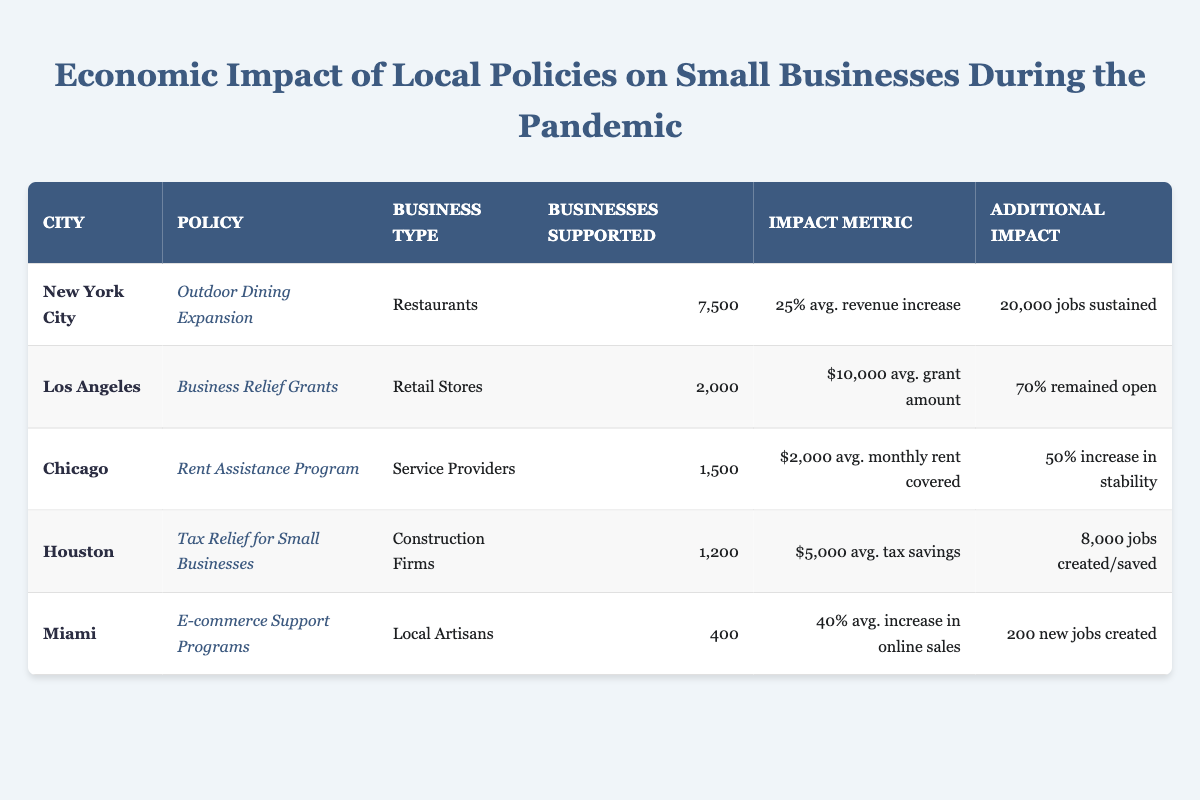What is the average revenue increase percentage for restaurants in New York City? The table indicates that the average revenue increase percentage for restaurants under the Outdoor Dining Expansion policy in New York City is 25%.
Answer: 25% How many small businesses were supported by the Business Relief Grants policy in Los Angeles? The table states that the Business Relief Grants policy in Los Angeles supported 2,000 retail stores.
Answer: 2000 Did the Rent Assistance Program in Chicago contribute to an increase in business stability? The table shows a 50% increase in business stability for service providers supported by the Rent Assistance Program. Therefore, the statement is true.
Answer: Yes What is the total number of businesses supported by all policies listed in the table? To find the total number of businesses supported, I sum the number of supported businesses for each city: 7500 (NYC) + 2000 (LA) + 1500 (Chicago) + 1200 (Houston) + 400 (Miami) = 13,600.
Answer: 13600 How many jobs were either created or saved due to tax relief for small businesses in Houston? According to the table, the Tax Relief for Small Businesses policy in Houston resulted in 8,000 jobs created or saved.
Answer: 8000 What percentage of businesses in Los Angeles remained open after receiving business relief grants? The table specifies that 70% of businesses remained open following the Business Relief Grants policy in Los Angeles.
Answer: 70% Which policy had the lowest number of businesses supported? The E-commerce Support Programs in Miami had the lowest number of businesses supported, with only 400 local artisans receiving support.
Answer: E-commerce Support Programs Calculate the average job impact across all policies listed in the table (considering only those that provide job metrics). The table shows job impact metrics for New York City (20,000 jobs sustained), Houston (8,000 jobs created or saved), and Miami (200 new jobs created). Summing these gives 20,000 + 8,000 + 200 = 28,200. Dividing by the number of policies (3) yields an average impact of 9,400 jobs.
Answer: 9400 